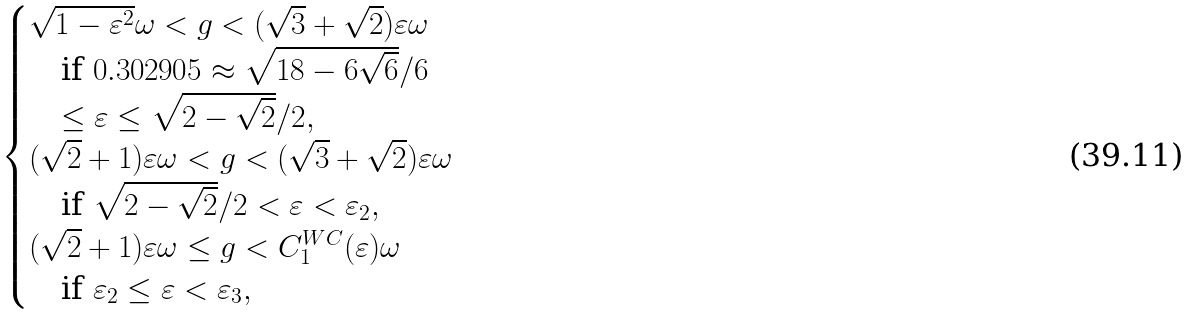Convert formula to latex. <formula><loc_0><loc_0><loc_500><loc_500>\begin{cases} \sqrt { 1 - \varepsilon ^ { 2 } } \omega < g < ( \sqrt { 3 } + \sqrt { 2 } ) \varepsilon \omega \\ \quad \text {if $0.302905 \approx \sqrt{18-6\sqrt{6}}/6$} \\ \quad \text {$\leq \varepsilon\leq\sqrt{2-\sqrt{2}}/2$} , \\ ( \sqrt { 2 } + 1 ) \varepsilon \omega < g < ( \sqrt { 3 } + \sqrt { 2 } ) \varepsilon \omega \\ \quad \text {if $\sqrt{2-\sqrt{2}}/2<\varepsilon<\varepsilon_{2}$} , \\ ( \sqrt { 2 } + 1 ) \varepsilon \omega \leq g < C _ { 1 } ^ { W C } ( \varepsilon ) \omega \\ \quad \text {if $\varepsilon_{2}\leq\varepsilon<\varepsilon_{3}$} , \end{cases}</formula> 